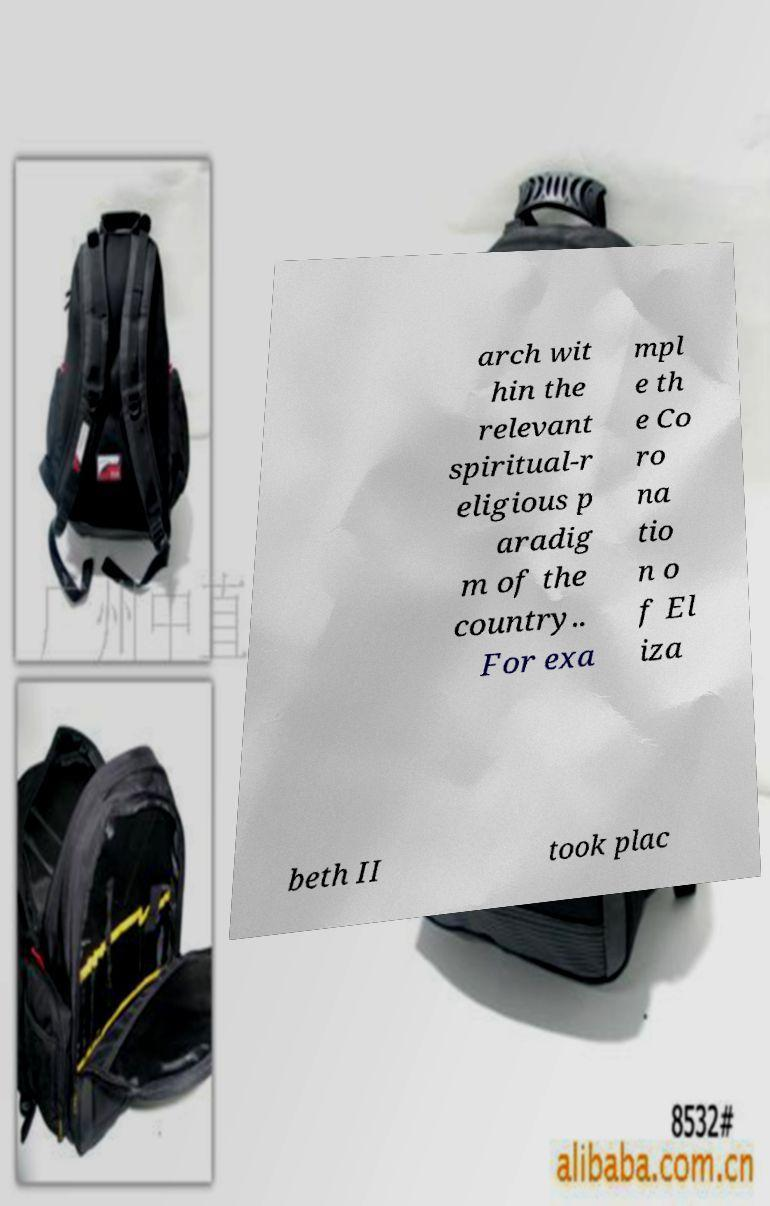Please identify and transcribe the text found in this image. arch wit hin the relevant spiritual-r eligious p aradig m of the country.. For exa mpl e th e Co ro na tio n o f El iza beth II took plac 